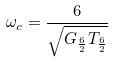<formula> <loc_0><loc_0><loc_500><loc_500>\omega _ { c } = \frac { 6 } { \sqrt { G _ { \frac { 6 } { 2 } } T _ { \frac { 6 } { 2 } } } }</formula> 